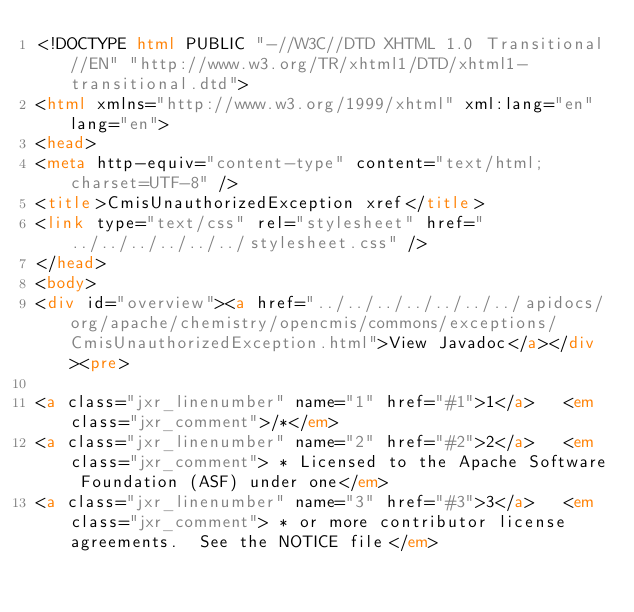<code> <loc_0><loc_0><loc_500><loc_500><_HTML_><!DOCTYPE html PUBLIC "-//W3C//DTD XHTML 1.0 Transitional//EN" "http://www.w3.org/TR/xhtml1/DTD/xhtml1-transitional.dtd">
<html xmlns="http://www.w3.org/1999/xhtml" xml:lang="en" lang="en">
<head>
<meta http-equiv="content-type" content="text/html; charset=UTF-8" />
<title>CmisUnauthorizedException xref</title>
<link type="text/css" rel="stylesheet" href="../../../../../../stylesheet.css" />
</head>
<body>
<div id="overview"><a href="../../../../../../../apidocs/org/apache/chemistry/opencmis/commons/exceptions/CmisUnauthorizedException.html">View Javadoc</a></div><pre>

<a class="jxr_linenumber" name="1" href="#1">1</a>   <em class="jxr_comment">/*</em>
<a class="jxr_linenumber" name="2" href="#2">2</a>   <em class="jxr_comment"> * Licensed to the Apache Software Foundation (ASF) under one</em>
<a class="jxr_linenumber" name="3" href="#3">3</a>   <em class="jxr_comment"> * or more contributor license agreements.  See the NOTICE file</em></code> 